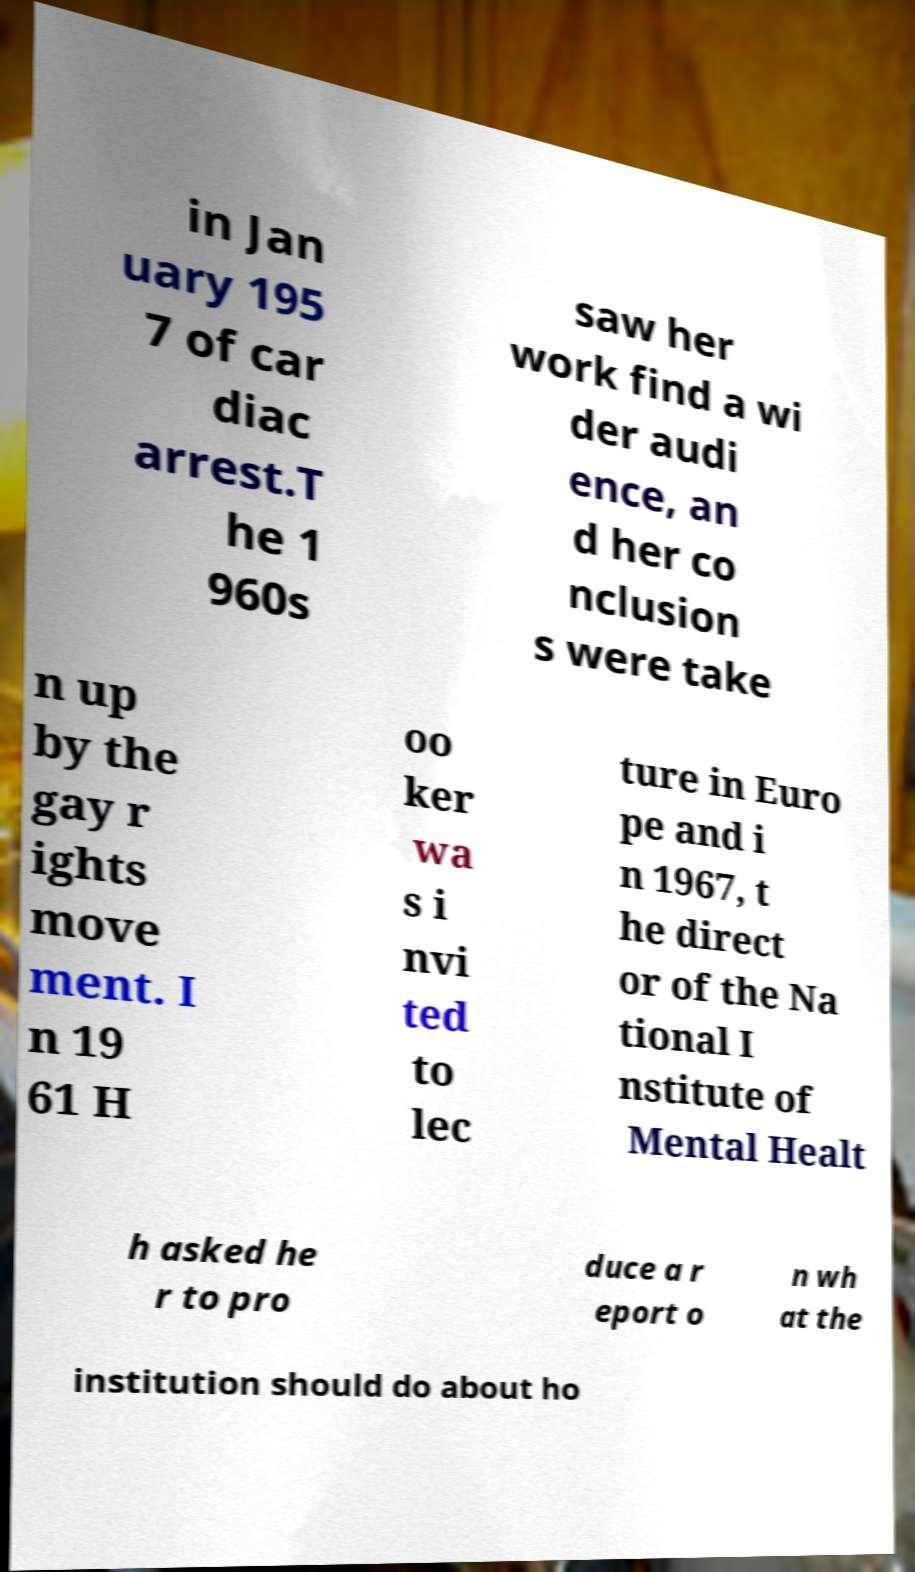For documentation purposes, I need the text within this image transcribed. Could you provide that? in Jan uary 195 7 of car diac arrest.T he 1 960s saw her work find a wi der audi ence, an d her co nclusion s were take n up by the gay r ights move ment. I n 19 61 H oo ker wa s i nvi ted to lec ture in Euro pe and i n 1967, t he direct or of the Na tional I nstitute of Mental Healt h asked he r to pro duce a r eport o n wh at the institution should do about ho 